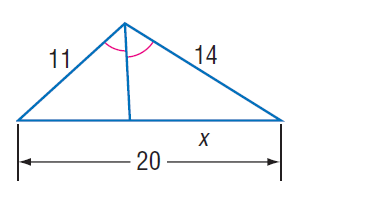Answer the mathemtical geometry problem and directly provide the correct option letter.
Question: Find x.
Choices: A: 10 B: 11 C: \frac { 56 } { 5 } D: 12 C 